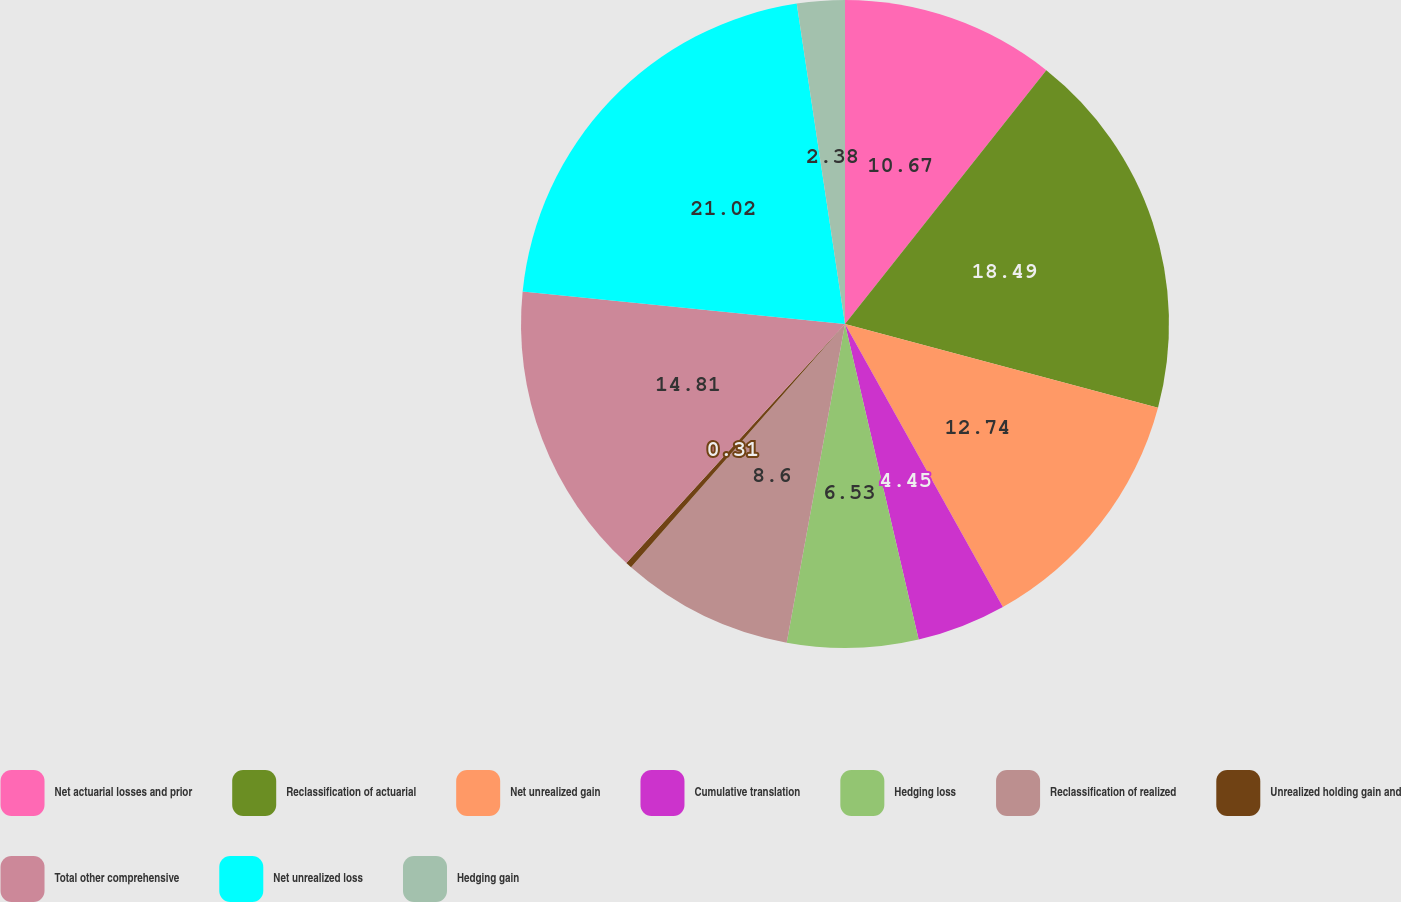Convert chart. <chart><loc_0><loc_0><loc_500><loc_500><pie_chart><fcel>Net actuarial losses and prior<fcel>Reclassification of actuarial<fcel>Net unrealized gain<fcel>Cumulative translation<fcel>Hedging loss<fcel>Reclassification of realized<fcel>Unrealized holding gain and<fcel>Total other comprehensive<fcel>Net unrealized loss<fcel>Hedging gain<nl><fcel>10.67%<fcel>18.49%<fcel>12.74%<fcel>4.45%<fcel>6.53%<fcel>8.6%<fcel>0.31%<fcel>14.81%<fcel>21.02%<fcel>2.38%<nl></chart> 